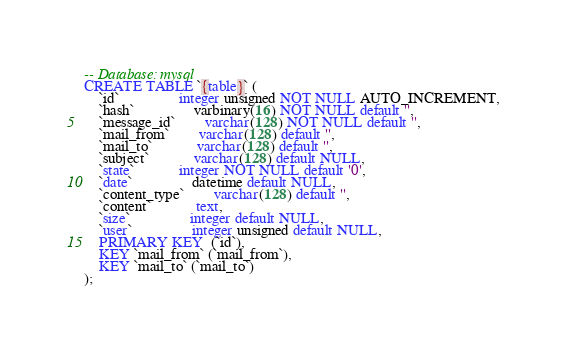<code> <loc_0><loc_0><loc_500><loc_500><_SQL_>-- Database: mysql
CREATE TABLE `{table}` (
	`id` 				integer unsigned NOT NULL AUTO_INCREMENT,
	`hash`		 		varbinary(16) NOT NULL default '',
	`message_id`		varchar(128) NOT NULL default '',
	`mail_from` 		varchar(128) default '',
	`mail_to` 			varchar(128) default '',
	`subject` 			varchar(128) default NULL,
	`state` 			integer NOT NULL default '0',
	`date` 				datetime default NULL,
	`content_type` 		varchar(128) default '',
	`content` 			text,
	`size` 				integer default NULL,
	`user` 				integer unsigned default NULL,
	PRIMARY KEY  (`id`),
	KEY `mail_from` (`mail_from`),
	KEY `mail_to` (`mail_to`)
);

</code> 